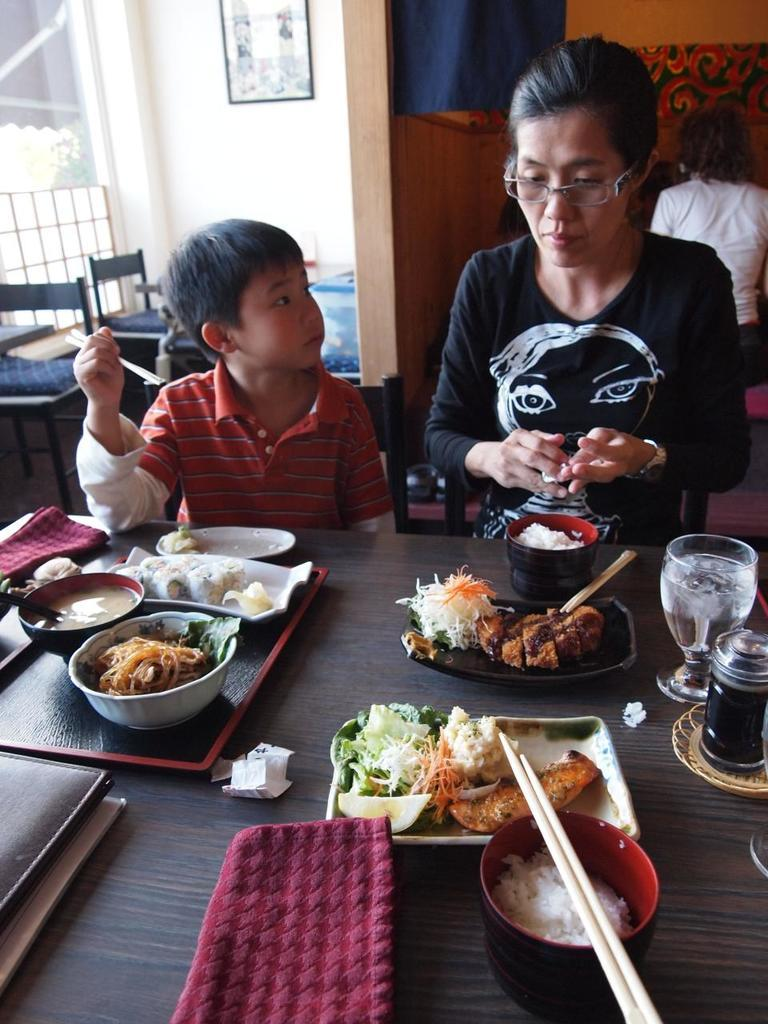What is present in the image that people typically use for eating or placing items? There is a table in the image. Who can be seen in the image? There is a woman and a boy in the image. What are the woman and boy doing in the image? The woman and boy are seated in front of the table. What is on the table that they might be using during their activity? There is food and glasses on the table. How many cats can be seen playing with the structure in the image? There are no cats or structures present in the image. What type of house is visible in the background of the image? There is no house visible in the image; it only shows a table, a woman, a boy, and items on the table. 